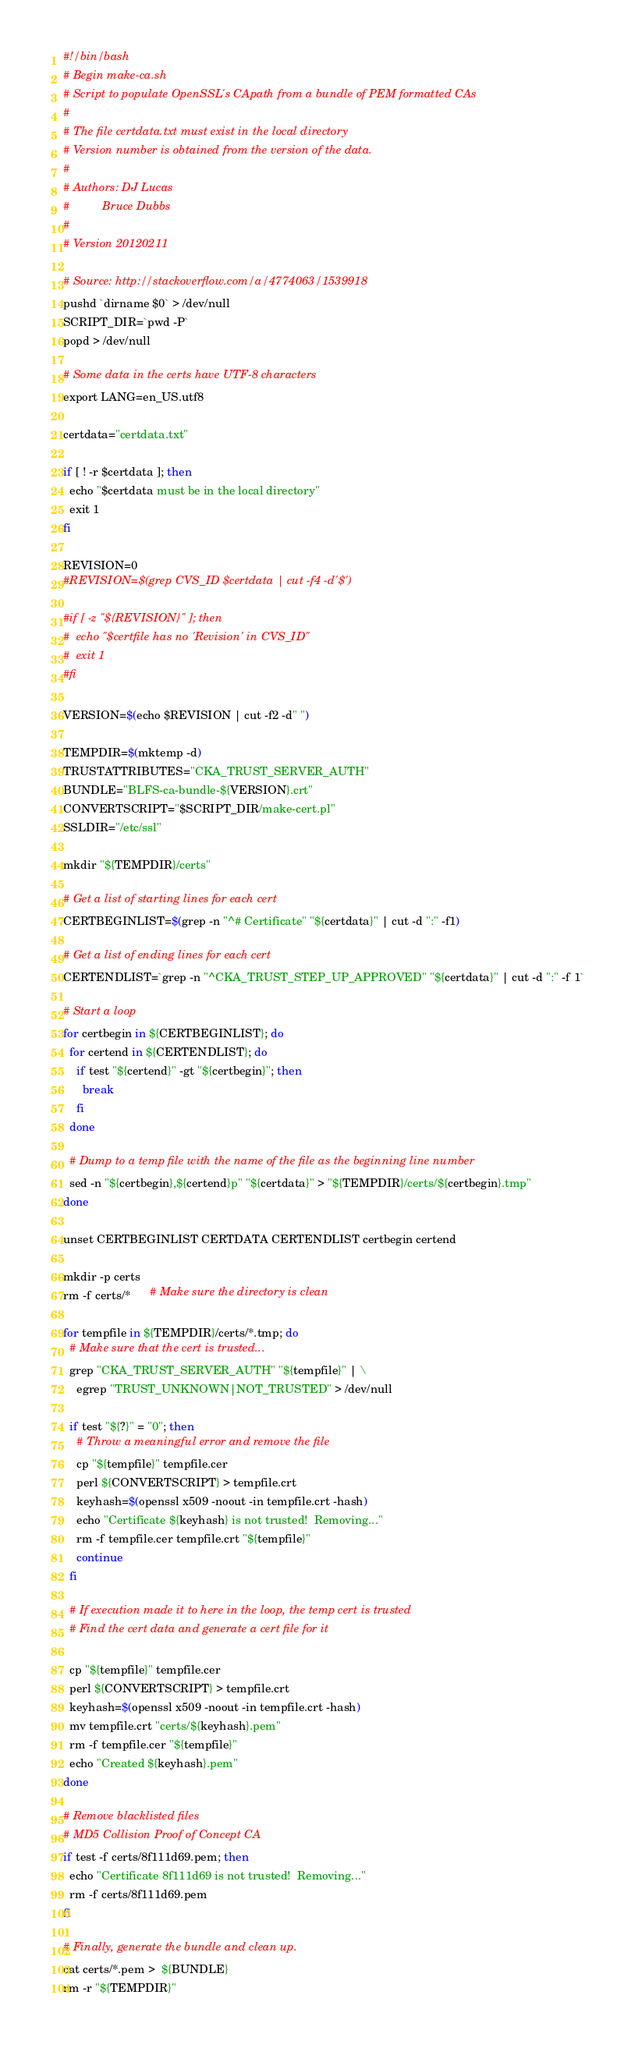<code> <loc_0><loc_0><loc_500><loc_500><_Bash_>#!/bin/bash
# Begin make-ca.sh
# Script to populate OpenSSL's CApath from a bundle of PEM formatted CAs
#
# The file certdata.txt must exist in the local directory
# Version number is obtained from the version of the data.
#
# Authors: DJ Lucas
#          Bruce Dubbs
#
# Version 20120211

# Source: http://stackoverflow.com/a/4774063/1539918
pushd `dirname $0` > /dev/null
SCRIPT_DIR=`pwd -P`
popd > /dev/null

# Some data in the certs have UTF-8 characters
export LANG=en_US.utf8

certdata="certdata.txt"

if [ ! -r $certdata ]; then
  echo "$certdata must be in the local directory"
  exit 1
fi

REVISION=0
#REVISION=$(grep CVS_ID $certdata | cut -f4 -d'$')

#if [ -z "${REVISION}" ]; then
#  echo "$certfile has no 'Revision' in CVS_ID"
#  exit 1
#fi

VERSION=$(echo $REVISION | cut -f2 -d" ")

TEMPDIR=$(mktemp -d)
TRUSTATTRIBUTES="CKA_TRUST_SERVER_AUTH"
BUNDLE="BLFS-ca-bundle-${VERSION}.crt"
CONVERTSCRIPT="$SCRIPT_DIR/make-cert.pl"
SSLDIR="/etc/ssl"

mkdir "${TEMPDIR}/certs"

# Get a list of starting lines for each cert
CERTBEGINLIST=$(grep -n "^# Certificate" "${certdata}" | cut -d ":" -f1)

# Get a list of ending lines for each cert
CERTENDLIST=`grep -n "^CKA_TRUST_STEP_UP_APPROVED" "${certdata}" | cut -d ":" -f 1`

# Start a loop
for certbegin in ${CERTBEGINLIST}; do
  for certend in ${CERTENDLIST}; do
    if test "${certend}" -gt "${certbegin}"; then
      break
    fi
  done

  # Dump to a temp file with the name of the file as the beginning line number
  sed -n "${certbegin},${certend}p" "${certdata}" > "${TEMPDIR}/certs/${certbegin}.tmp"
done

unset CERTBEGINLIST CERTDATA CERTENDLIST certbegin certend

mkdir -p certs
rm -f certs/*      # Make sure the directory is clean

for tempfile in ${TEMPDIR}/certs/*.tmp; do
  # Make sure that the cert is trusted...
  grep "CKA_TRUST_SERVER_AUTH" "${tempfile}" | \
    egrep "TRUST_UNKNOWN|NOT_TRUSTED" > /dev/null

  if test "${?}" = "0"; then
    # Throw a meaningful error and remove the file
    cp "${tempfile}" tempfile.cer
    perl ${CONVERTSCRIPT} > tempfile.crt
    keyhash=$(openssl x509 -noout -in tempfile.crt -hash)
    echo "Certificate ${keyhash} is not trusted!  Removing..."
    rm -f tempfile.cer tempfile.crt "${tempfile}"
    continue
  fi

  # If execution made it to here in the loop, the temp cert is trusted
  # Find the cert data and generate a cert file for it

  cp "${tempfile}" tempfile.cer
  perl ${CONVERTSCRIPT} > tempfile.crt
  keyhash=$(openssl x509 -noout -in tempfile.crt -hash)
  mv tempfile.crt "certs/${keyhash}.pem"
  rm -f tempfile.cer "${tempfile}"
  echo "Created ${keyhash}.pem"
done

# Remove blacklisted files
# MD5 Collision Proof of Concept CA
if test -f certs/8f111d69.pem; then
  echo "Certificate 8f111d69 is not trusted!  Removing..."
  rm -f certs/8f111d69.pem
fi

# Finally, generate the bundle and clean up.
cat certs/*.pem >  ${BUNDLE}
rm -r "${TEMPDIR}"
</code> 